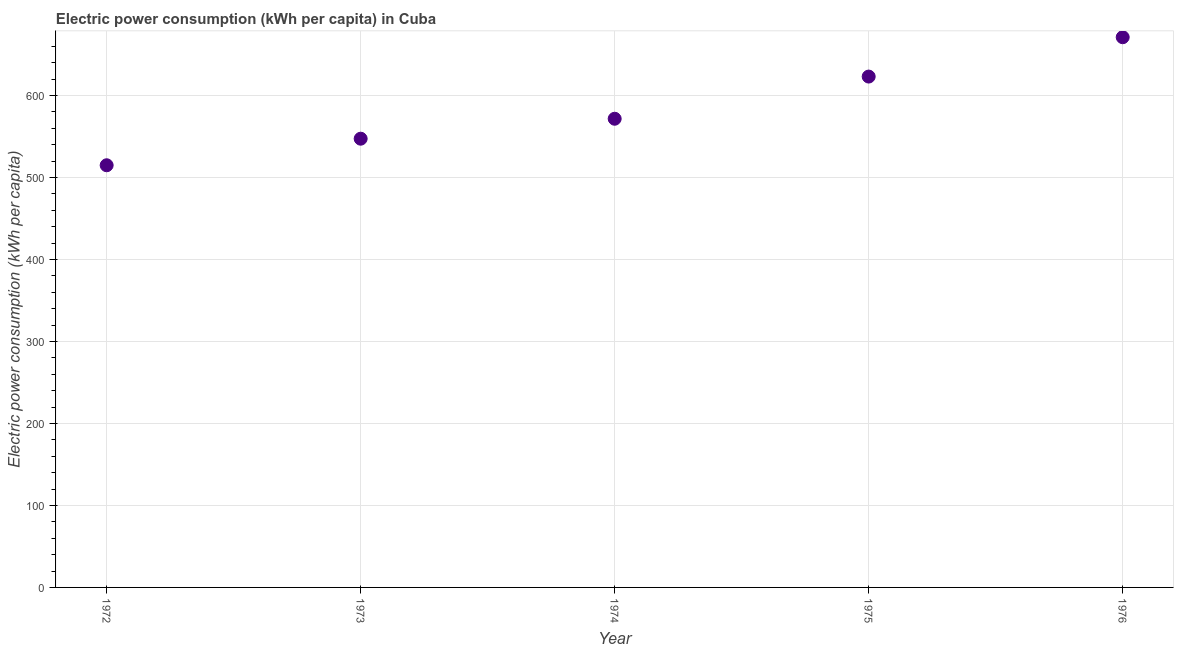What is the electric power consumption in 1975?
Provide a short and direct response. 623.2. Across all years, what is the maximum electric power consumption?
Your response must be concise. 671.19. Across all years, what is the minimum electric power consumption?
Offer a very short reply. 515. In which year was the electric power consumption maximum?
Your answer should be compact. 1976. In which year was the electric power consumption minimum?
Provide a succinct answer. 1972. What is the sum of the electric power consumption?
Offer a terse response. 2928.53. What is the difference between the electric power consumption in 1973 and 1976?
Make the answer very short. -123.78. What is the average electric power consumption per year?
Make the answer very short. 585.71. What is the median electric power consumption?
Offer a terse response. 571.74. In how many years, is the electric power consumption greater than 400 kWh per capita?
Offer a terse response. 5. Do a majority of the years between 1975 and 1973 (inclusive) have electric power consumption greater than 440 kWh per capita?
Your answer should be compact. No. What is the ratio of the electric power consumption in 1973 to that in 1976?
Provide a succinct answer. 0.82. Is the electric power consumption in 1973 less than that in 1975?
Offer a very short reply. Yes. Is the difference between the electric power consumption in 1972 and 1974 greater than the difference between any two years?
Make the answer very short. No. What is the difference between the highest and the second highest electric power consumption?
Keep it short and to the point. 47.99. What is the difference between the highest and the lowest electric power consumption?
Your response must be concise. 156.19. How many dotlines are there?
Provide a short and direct response. 1. How many years are there in the graph?
Keep it short and to the point. 5. Are the values on the major ticks of Y-axis written in scientific E-notation?
Keep it short and to the point. No. What is the title of the graph?
Make the answer very short. Electric power consumption (kWh per capita) in Cuba. What is the label or title of the Y-axis?
Make the answer very short. Electric power consumption (kWh per capita). What is the Electric power consumption (kWh per capita) in 1972?
Ensure brevity in your answer.  515. What is the Electric power consumption (kWh per capita) in 1973?
Offer a very short reply. 547.4. What is the Electric power consumption (kWh per capita) in 1974?
Keep it short and to the point. 571.74. What is the Electric power consumption (kWh per capita) in 1975?
Your answer should be very brief. 623.2. What is the Electric power consumption (kWh per capita) in 1976?
Your response must be concise. 671.19. What is the difference between the Electric power consumption (kWh per capita) in 1972 and 1973?
Offer a terse response. -32.41. What is the difference between the Electric power consumption (kWh per capita) in 1972 and 1974?
Ensure brevity in your answer.  -56.75. What is the difference between the Electric power consumption (kWh per capita) in 1972 and 1975?
Your response must be concise. -108.2. What is the difference between the Electric power consumption (kWh per capita) in 1972 and 1976?
Your answer should be very brief. -156.19. What is the difference between the Electric power consumption (kWh per capita) in 1973 and 1974?
Ensure brevity in your answer.  -24.34. What is the difference between the Electric power consumption (kWh per capita) in 1973 and 1975?
Provide a succinct answer. -75.79. What is the difference between the Electric power consumption (kWh per capita) in 1973 and 1976?
Keep it short and to the point. -123.78. What is the difference between the Electric power consumption (kWh per capita) in 1974 and 1975?
Provide a short and direct response. -51.45. What is the difference between the Electric power consumption (kWh per capita) in 1974 and 1976?
Keep it short and to the point. -99.44. What is the difference between the Electric power consumption (kWh per capita) in 1975 and 1976?
Keep it short and to the point. -47.99. What is the ratio of the Electric power consumption (kWh per capita) in 1972 to that in 1973?
Offer a terse response. 0.94. What is the ratio of the Electric power consumption (kWh per capita) in 1972 to that in 1974?
Your response must be concise. 0.9. What is the ratio of the Electric power consumption (kWh per capita) in 1972 to that in 1975?
Your response must be concise. 0.83. What is the ratio of the Electric power consumption (kWh per capita) in 1972 to that in 1976?
Give a very brief answer. 0.77. What is the ratio of the Electric power consumption (kWh per capita) in 1973 to that in 1974?
Keep it short and to the point. 0.96. What is the ratio of the Electric power consumption (kWh per capita) in 1973 to that in 1975?
Offer a very short reply. 0.88. What is the ratio of the Electric power consumption (kWh per capita) in 1973 to that in 1976?
Give a very brief answer. 0.82. What is the ratio of the Electric power consumption (kWh per capita) in 1974 to that in 1975?
Provide a succinct answer. 0.92. What is the ratio of the Electric power consumption (kWh per capita) in 1974 to that in 1976?
Keep it short and to the point. 0.85. What is the ratio of the Electric power consumption (kWh per capita) in 1975 to that in 1976?
Your answer should be very brief. 0.93. 